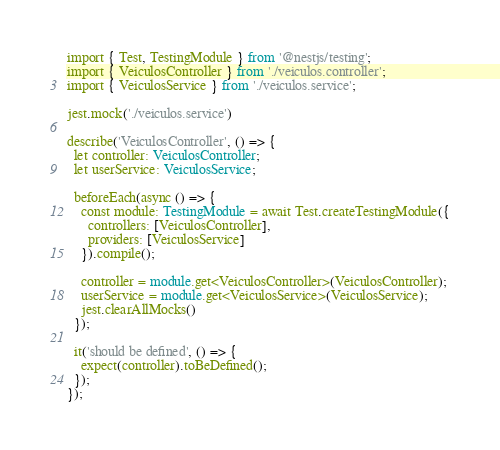Convert code to text. <code><loc_0><loc_0><loc_500><loc_500><_TypeScript_>import { Test, TestingModule } from '@nestjs/testing';
import { VeiculosController } from './veiculos.controller';
import { VeiculosService } from './veiculos.service';

jest.mock('./veiculos.service')

describe('VeiculosController', () => {
  let controller: VeiculosController;
  let userService: VeiculosService;

  beforeEach(async () => {
    const module: TestingModule = await Test.createTestingModule({
      controllers: [VeiculosController],
      providers: [VeiculosService]
    }).compile();

    controller = module.get<VeiculosController>(VeiculosController);
    userService = module.get<VeiculosService>(VeiculosService);
    jest.clearAllMocks()
  });

  it('should be defined', () => {
    expect(controller).toBeDefined();
  });
});
</code> 